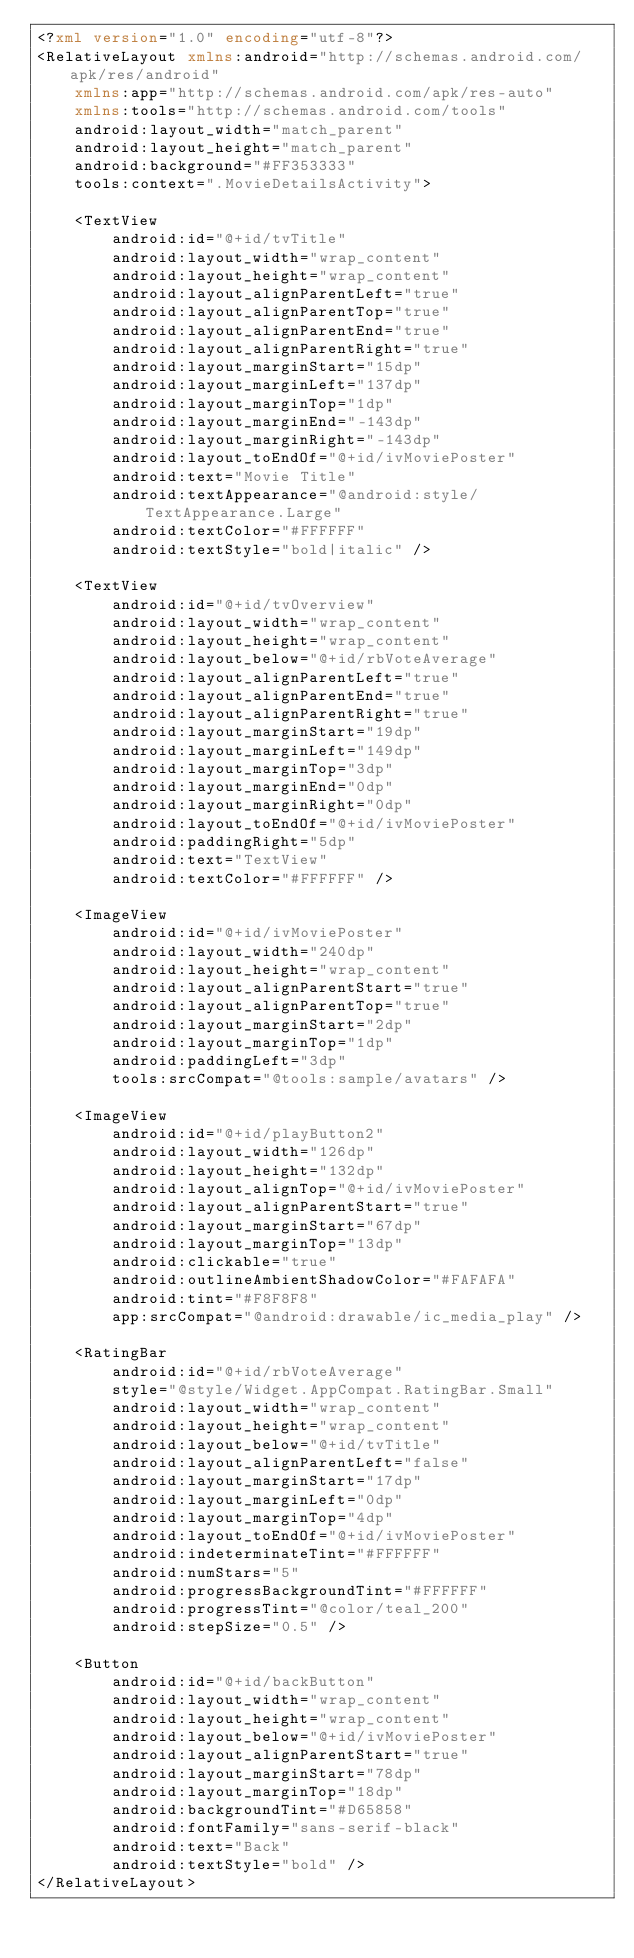<code> <loc_0><loc_0><loc_500><loc_500><_XML_><?xml version="1.0" encoding="utf-8"?>
<RelativeLayout xmlns:android="http://schemas.android.com/apk/res/android"
    xmlns:app="http://schemas.android.com/apk/res-auto"
    xmlns:tools="http://schemas.android.com/tools"
    android:layout_width="match_parent"
    android:layout_height="match_parent"
    android:background="#FF353333"
    tools:context=".MovieDetailsActivity">

    <TextView
        android:id="@+id/tvTitle"
        android:layout_width="wrap_content"
        android:layout_height="wrap_content"
        android:layout_alignParentLeft="true"
        android:layout_alignParentTop="true"
        android:layout_alignParentEnd="true"
        android:layout_alignParentRight="true"
        android:layout_marginStart="15dp"
        android:layout_marginLeft="137dp"
        android:layout_marginTop="1dp"
        android:layout_marginEnd="-143dp"
        android:layout_marginRight="-143dp"
        android:layout_toEndOf="@+id/ivMoviePoster"
        android:text="Movie Title"
        android:textAppearance="@android:style/TextAppearance.Large"
        android:textColor="#FFFFFF"
        android:textStyle="bold|italic" />

    <TextView
        android:id="@+id/tvOverview"
        android:layout_width="wrap_content"
        android:layout_height="wrap_content"
        android:layout_below="@+id/rbVoteAverage"
        android:layout_alignParentLeft="true"
        android:layout_alignParentEnd="true"
        android:layout_alignParentRight="true"
        android:layout_marginStart="19dp"
        android:layout_marginLeft="149dp"
        android:layout_marginTop="3dp"
        android:layout_marginEnd="0dp"
        android:layout_marginRight="0dp"
        android:layout_toEndOf="@+id/ivMoviePoster"
        android:paddingRight="5dp"
        android:text="TextView"
        android:textColor="#FFFFFF" />

    <ImageView
        android:id="@+id/ivMoviePoster"
        android:layout_width="240dp"
        android:layout_height="wrap_content"
        android:layout_alignParentStart="true"
        android:layout_alignParentTop="true"
        android:layout_marginStart="2dp"
        android:layout_marginTop="1dp"
        android:paddingLeft="3dp"
        tools:srcCompat="@tools:sample/avatars" />

    <ImageView
        android:id="@+id/playButton2"
        android:layout_width="126dp"
        android:layout_height="132dp"
        android:layout_alignTop="@+id/ivMoviePoster"
        android:layout_alignParentStart="true"
        android:layout_marginStart="67dp"
        android:layout_marginTop="13dp"
        android:clickable="true"
        android:outlineAmbientShadowColor="#FAFAFA"
        android:tint="#F8F8F8"
        app:srcCompat="@android:drawable/ic_media_play" />

    <RatingBar
        android:id="@+id/rbVoteAverage"
        style="@style/Widget.AppCompat.RatingBar.Small"
        android:layout_width="wrap_content"
        android:layout_height="wrap_content"
        android:layout_below="@+id/tvTitle"
        android:layout_alignParentLeft="false"
        android:layout_marginStart="17dp"
        android:layout_marginLeft="0dp"
        android:layout_marginTop="4dp"
        android:layout_toEndOf="@+id/ivMoviePoster"
        android:indeterminateTint="#FFFFFF"
        android:numStars="5"
        android:progressBackgroundTint="#FFFFFF"
        android:progressTint="@color/teal_200"
        android:stepSize="0.5" />

    <Button
        android:id="@+id/backButton"
        android:layout_width="wrap_content"
        android:layout_height="wrap_content"
        android:layout_below="@+id/ivMoviePoster"
        android:layout_alignParentStart="true"
        android:layout_marginStart="78dp"
        android:layout_marginTop="18dp"
        android:backgroundTint="#D65858"
        android:fontFamily="sans-serif-black"
        android:text="Back"
        android:textStyle="bold" />
</RelativeLayout></code> 